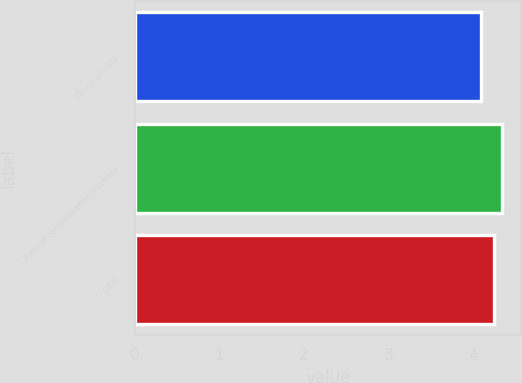<chart> <loc_0><loc_0><loc_500><loc_500><bar_chart><fcel>Discount rate<fcel>Rate of compensation increase<fcel>- O&R<nl><fcel>4.1<fcel>4.35<fcel>4.25<nl></chart> 